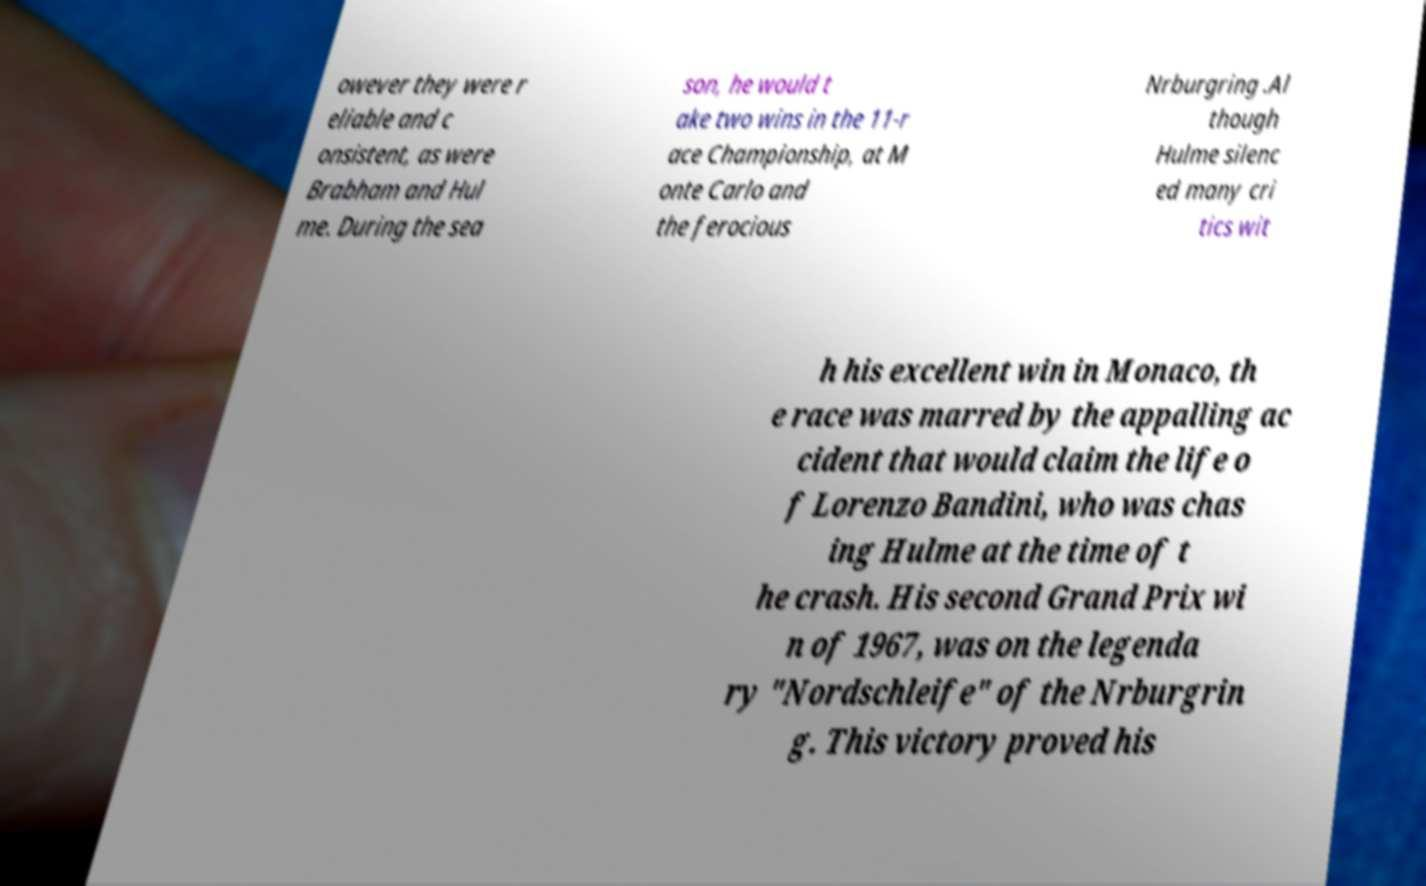Could you assist in decoding the text presented in this image and type it out clearly? owever they were r eliable and c onsistent, as were Brabham and Hul me. During the sea son, he would t ake two wins in the 11-r ace Championship, at M onte Carlo and the ferocious Nrburgring .Al though Hulme silenc ed many cri tics wit h his excellent win in Monaco, th e race was marred by the appalling ac cident that would claim the life o f Lorenzo Bandini, who was chas ing Hulme at the time of t he crash. His second Grand Prix wi n of 1967, was on the legenda ry "Nordschleife" of the Nrburgrin g. This victory proved his 